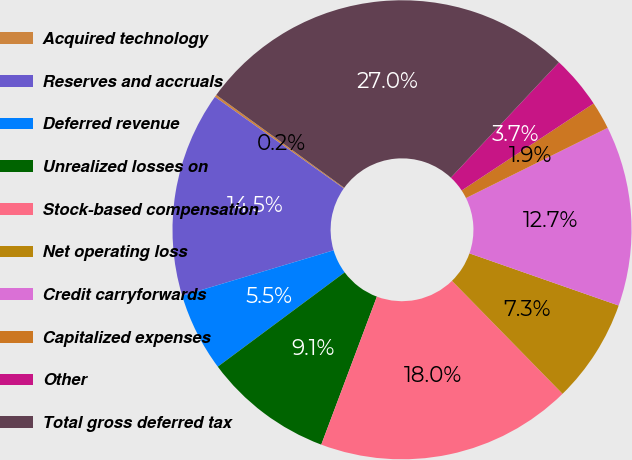<chart> <loc_0><loc_0><loc_500><loc_500><pie_chart><fcel>Acquired technology<fcel>Reserves and accruals<fcel>Deferred revenue<fcel>Unrealized losses on<fcel>Stock-based compensation<fcel>Net operating loss<fcel>Credit carryforwards<fcel>Capitalized expenses<fcel>Other<fcel>Total gross deferred tax<nl><fcel>0.17%<fcel>14.47%<fcel>5.53%<fcel>9.11%<fcel>18.05%<fcel>7.32%<fcel>12.68%<fcel>1.95%<fcel>3.74%<fcel>26.99%<nl></chart> 